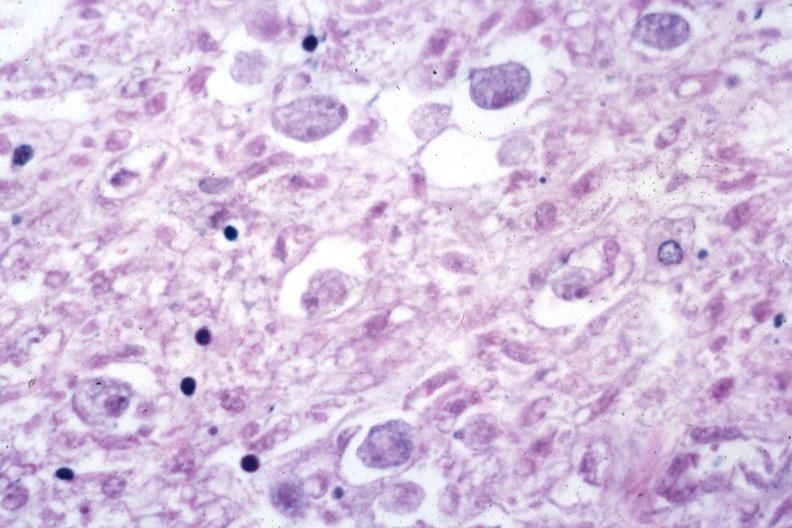does intrauterine contraceptive device show trophozoites in tissue?
Answer the question using a single word or phrase. No 